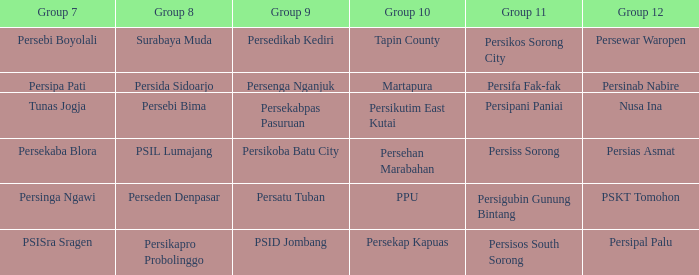Who played in group 12 when persikutim east kutai played in group 10? Nusa Ina. 